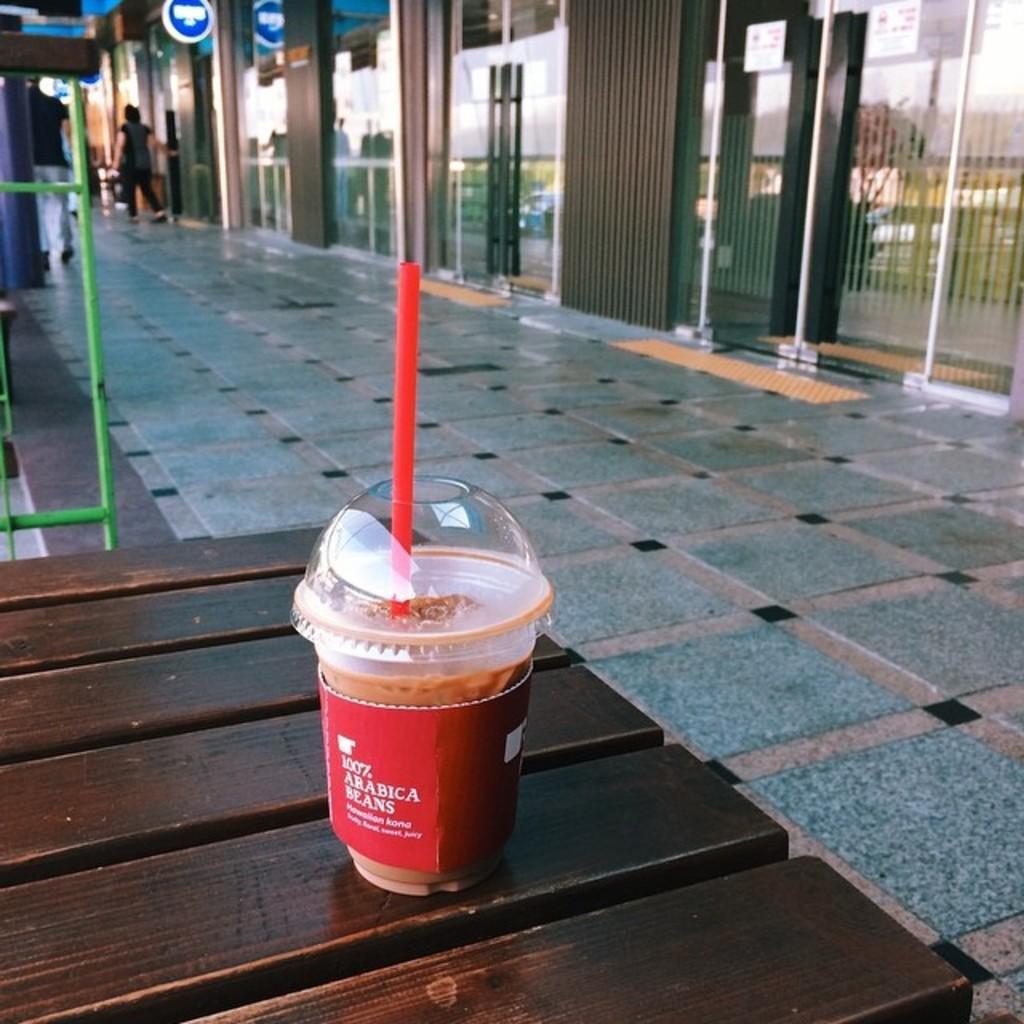Describe this image in one or two sentences. As we can see in the image there are buildings, few people here and there and a table. On table there is glass. 